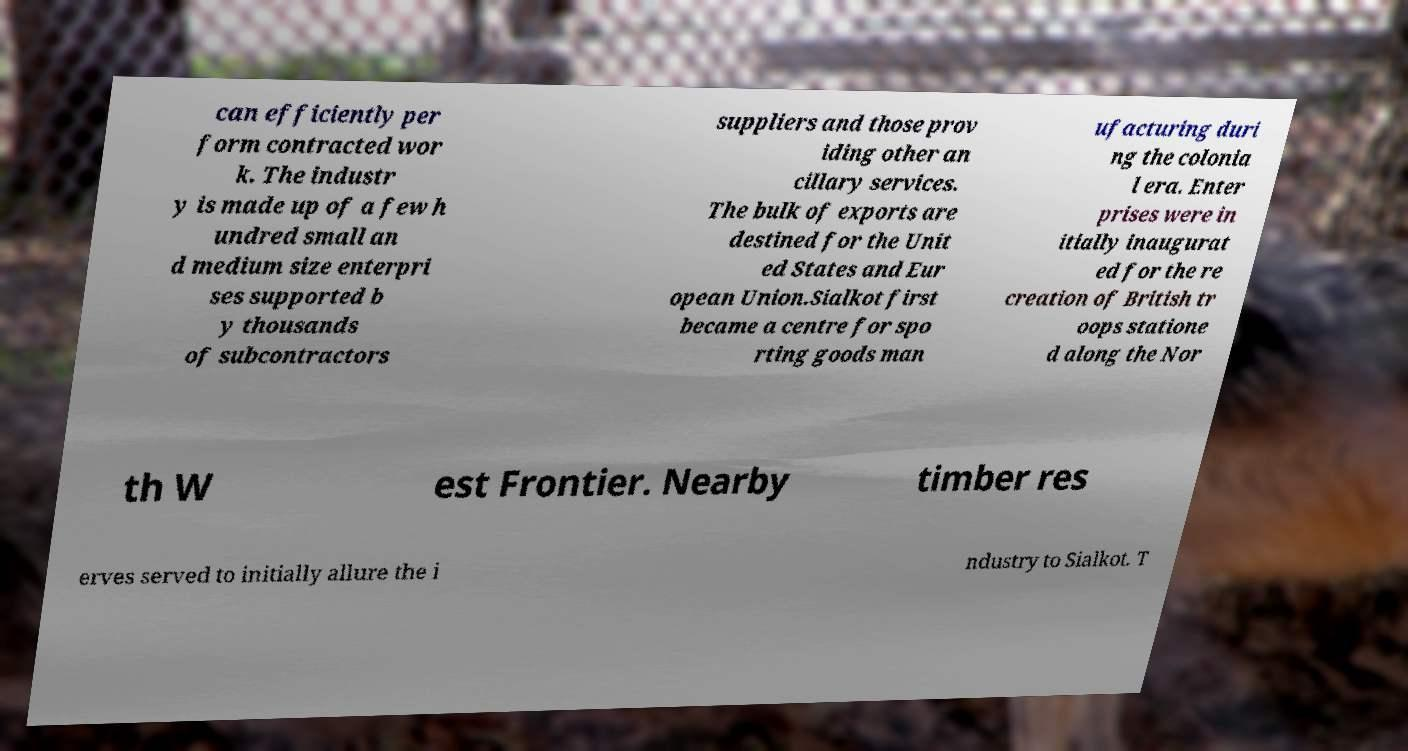Can you accurately transcribe the text from the provided image for me? can efficiently per form contracted wor k. The industr y is made up of a few h undred small an d medium size enterpri ses supported b y thousands of subcontractors suppliers and those prov iding other an cillary services. The bulk of exports are destined for the Unit ed States and Eur opean Union.Sialkot first became a centre for spo rting goods man ufacturing duri ng the colonia l era. Enter prises were in itially inaugurat ed for the re creation of British tr oops statione d along the Nor th W est Frontier. Nearby timber res erves served to initially allure the i ndustry to Sialkot. T 